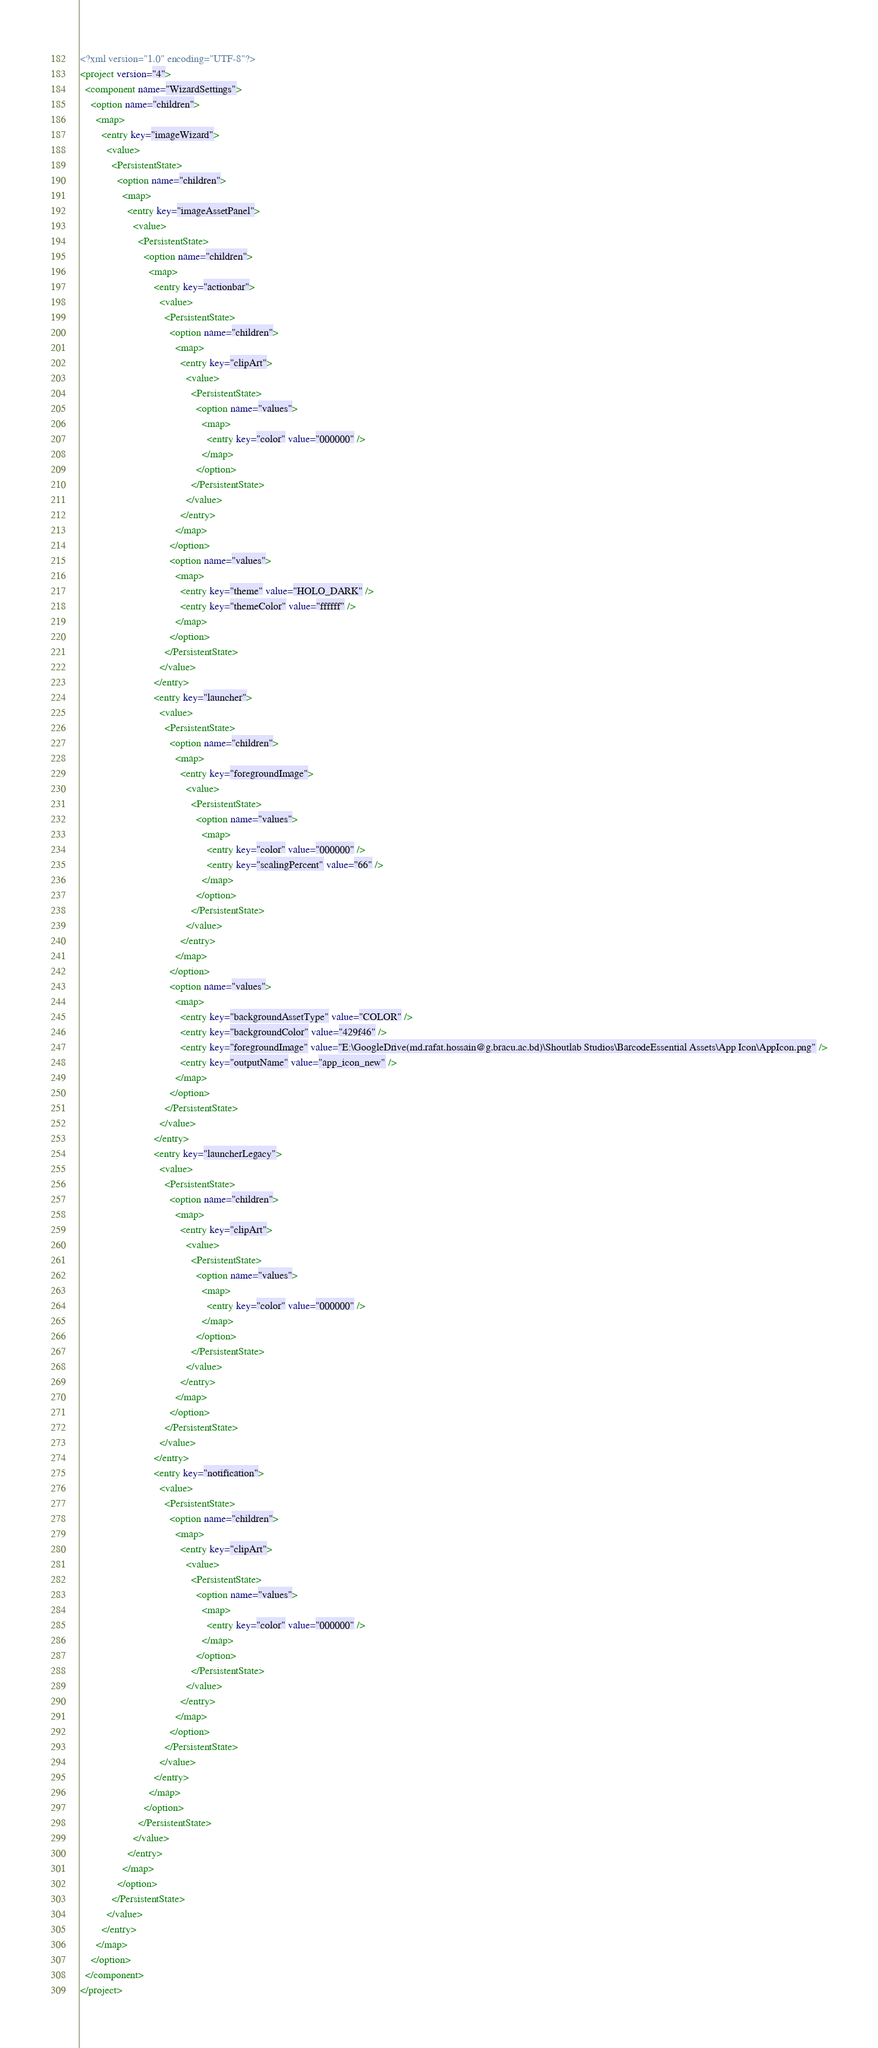<code> <loc_0><loc_0><loc_500><loc_500><_XML_><?xml version="1.0" encoding="UTF-8"?>
<project version="4">
  <component name="WizardSettings">
    <option name="children">
      <map>
        <entry key="imageWizard">
          <value>
            <PersistentState>
              <option name="children">
                <map>
                  <entry key="imageAssetPanel">
                    <value>
                      <PersistentState>
                        <option name="children">
                          <map>
                            <entry key="actionbar">
                              <value>
                                <PersistentState>
                                  <option name="children">
                                    <map>
                                      <entry key="clipArt">
                                        <value>
                                          <PersistentState>
                                            <option name="values">
                                              <map>
                                                <entry key="color" value="000000" />
                                              </map>
                                            </option>
                                          </PersistentState>
                                        </value>
                                      </entry>
                                    </map>
                                  </option>
                                  <option name="values">
                                    <map>
                                      <entry key="theme" value="HOLO_DARK" />
                                      <entry key="themeColor" value="ffffff" />
                                    </map>
                                  </option>
                                </PersistentState>
                              </value>
                            </entry>
                            <entry key="launcher">
                              <value>
                                <PersistentState>
                                  <option name="children">
                                    <map>
                                      <entry key="foregroundImage">
                                        <value>
                                          <PersistentState>
                                            <option name="values">
                                              <map>
                                                <entry key="color" value="000000" />
                                                <entry key="scalingPercent" value="66" />
                                              </map>
                                            </option>
                                          </PersistentState>
                                        </value>
                                      </entry>
                                    </map>
                                  </option>
                                  <option name="values">
                                    <map>
                                      <entry key="backgroundAssetType" value="COLOR" />
                                      <entry key="backgroundColor" value="429f46" />
                                      <entry key="foregroundImage" value="E:\GoogleDrive(md.rafat.hossain@g.bracu.ac.bd)\Shoutlab Studios\BarcodeEssential Assets\App Icon\AppIcon.png" />
                                      <entry key="outputName" value="app_icon_new" />
                                    </map>
                                  </option>
                                </PersistentState>
                              </value>
                            </entry>
                            <entry key="launcherLegacy">
                              <value>
                                <PersistentState>
                                  <option name="children">
                                    <map>
                                      <entry key="clipArt">
                                        <value>
                                          <PersistentState>
                                            <option name="values">
                                              <map>
                                                <entry key="color" value="000000" />
                                              </map>
                                            </option>
                                          </PersistentState>
                                        </value>
                                      </entry>
                                    </map>
                                  </option>
                                </PersistentState>
                              </value>
                            </entry>
                            <entry key="notification">
                              <value>
                                <PersistentState>
                                  <option name="children">
                                    <map>
                                      <entry key="clipArt">
                                        <value>
                                          <PersistentState>
                                            <option name="values">
                                              <map>
                                                <entry key="color" value="000000" />
                                              </map>
                                            </option>
                                          </PersistentState>
                                        </value>
                                      </entry>
                                    </map>
                                  </option>
                                </PersistentState>
                              </value>
                            </entry>
                          </map>
                        </option>
                      </PersistentState>
                    </value>
                  </entry>
                </map>
              </option>
            </PersistentState>
          </value>
        </entry>
      </map>
    </option>
  </component>
</project></code> 